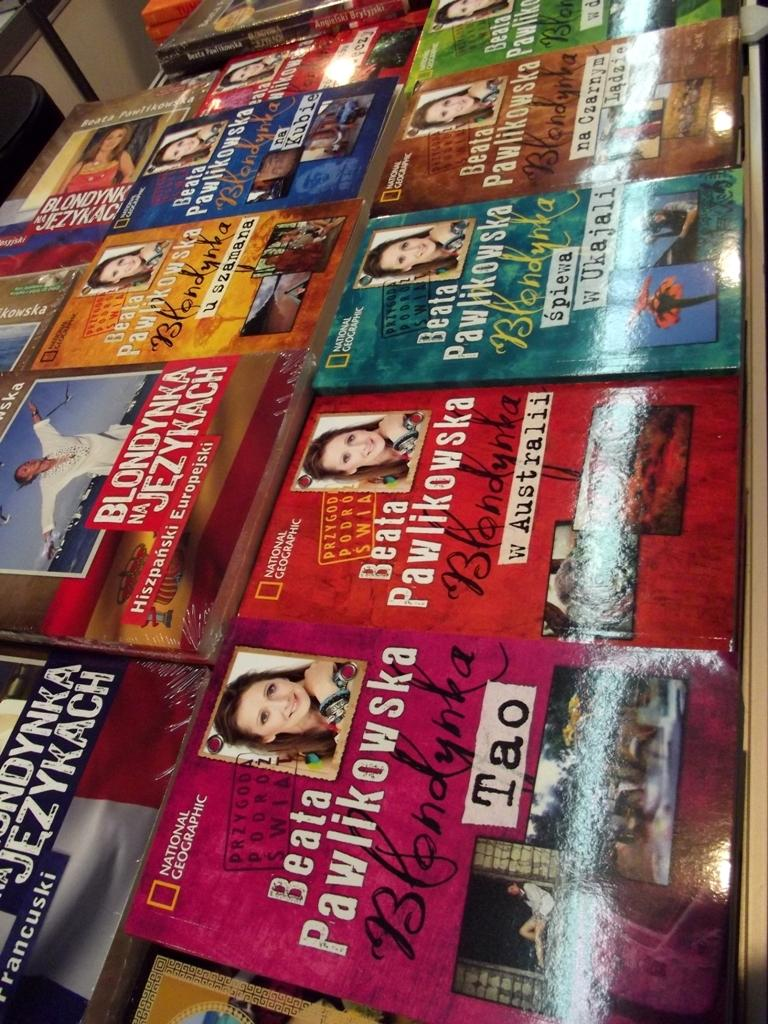<image>
Describe the image concisely. Bunch of books by Beata pawlikowska on a shelf that is national geographic 